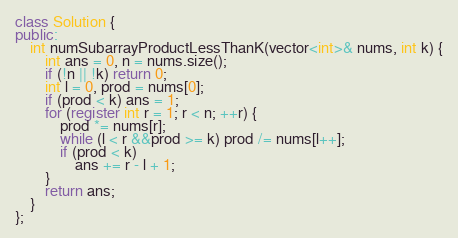Convert code to text. <code><loc_0><loc_0><loc_500><loc_500><_C++_>class Solution {
public:
    int numSubarrayProductLessThanK(vector<int>& nums, int k) {
        int ans = 0, n = nums.size();
        if (!n || !k) return 0;
        int l = 0, prod = nums[0];
        if (prod < k) ans = 1;
        for (register int r = 1; r < n; ++r) {
            prod *= nums[r];
            while (l < r &&prod >= k) prod /= nums[l++];
            if (prod < k)
                ans += r - l + 1;
        }
        return ans;
    }
};</code> 